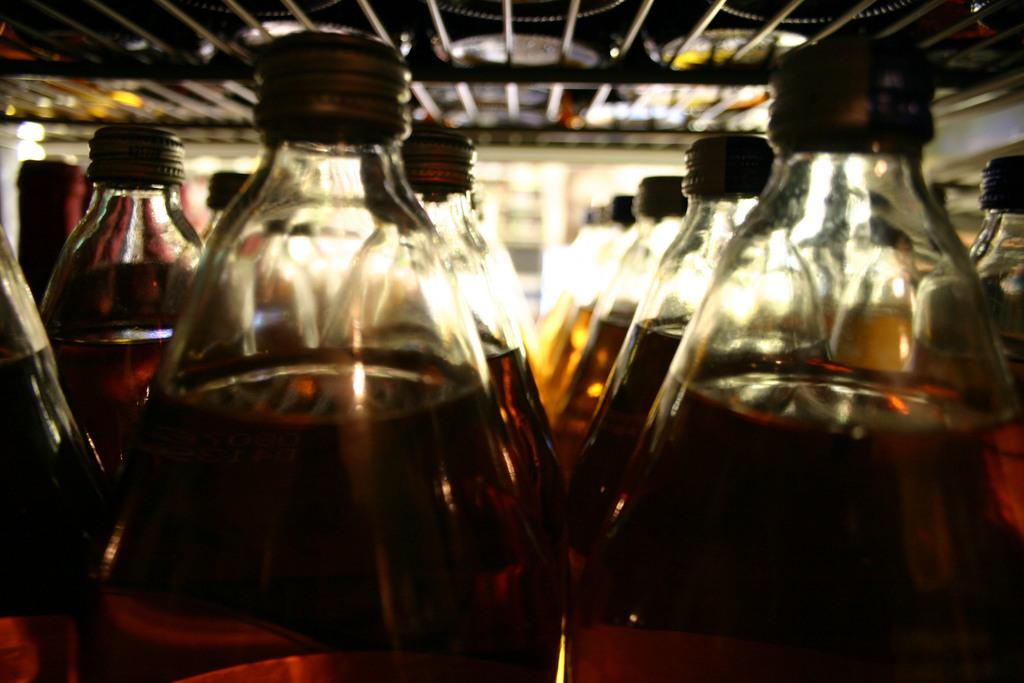What is inside the bottles in the image? The bottles are filled with a drink. What feature do the bottles have to prevent the drink from spilling? The bottles have caps. What can be seen at the top of the image? There is a grill at the top of the image. How many baby birds are in the flock that is sitting on the grill in the image? There are no baby birds or flock present in the image; it only features bottles and a grill. 